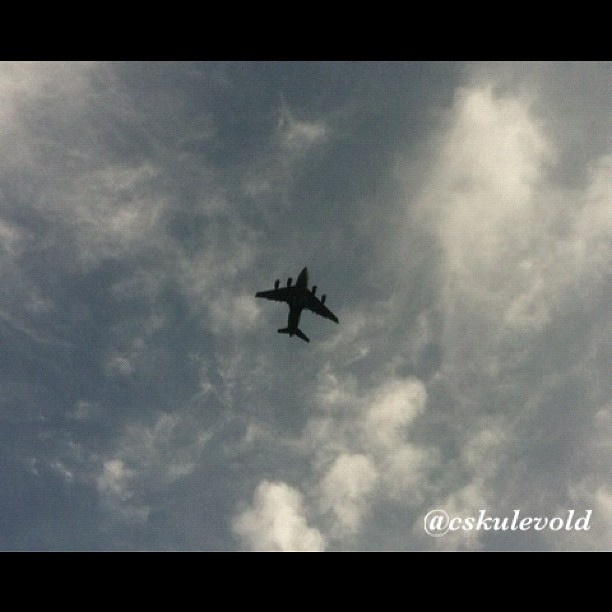Describe the objects in this image and their specific colors. I can see a airplane in black, gray, and purple tones in this image. 